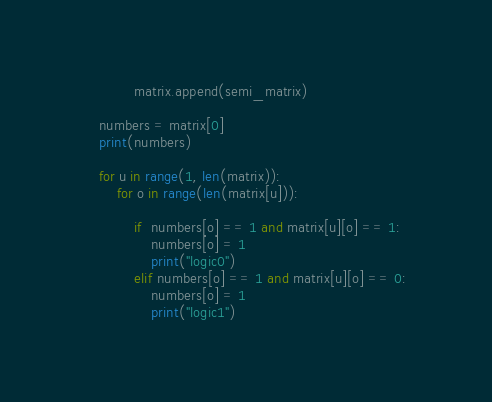Convert code to text. <code><loc_0><loc_0><loc_500><loc_500><_Python_>            matrix.append(semi_matrix)

    numbers = matrix[0]
    print(numbers)

    for u in range(1, len(matrix)):
        for o in range(len(matrix[u])):

            if  numbers[o] == 1 and matrix[u][o] == 1: 
                numbers[o] = 1
                print("logic0")
            elif numbers[o] == 1 and matrix[u][o] == 0: 
                numbers[o] = 1
                print("logic1")</code> 